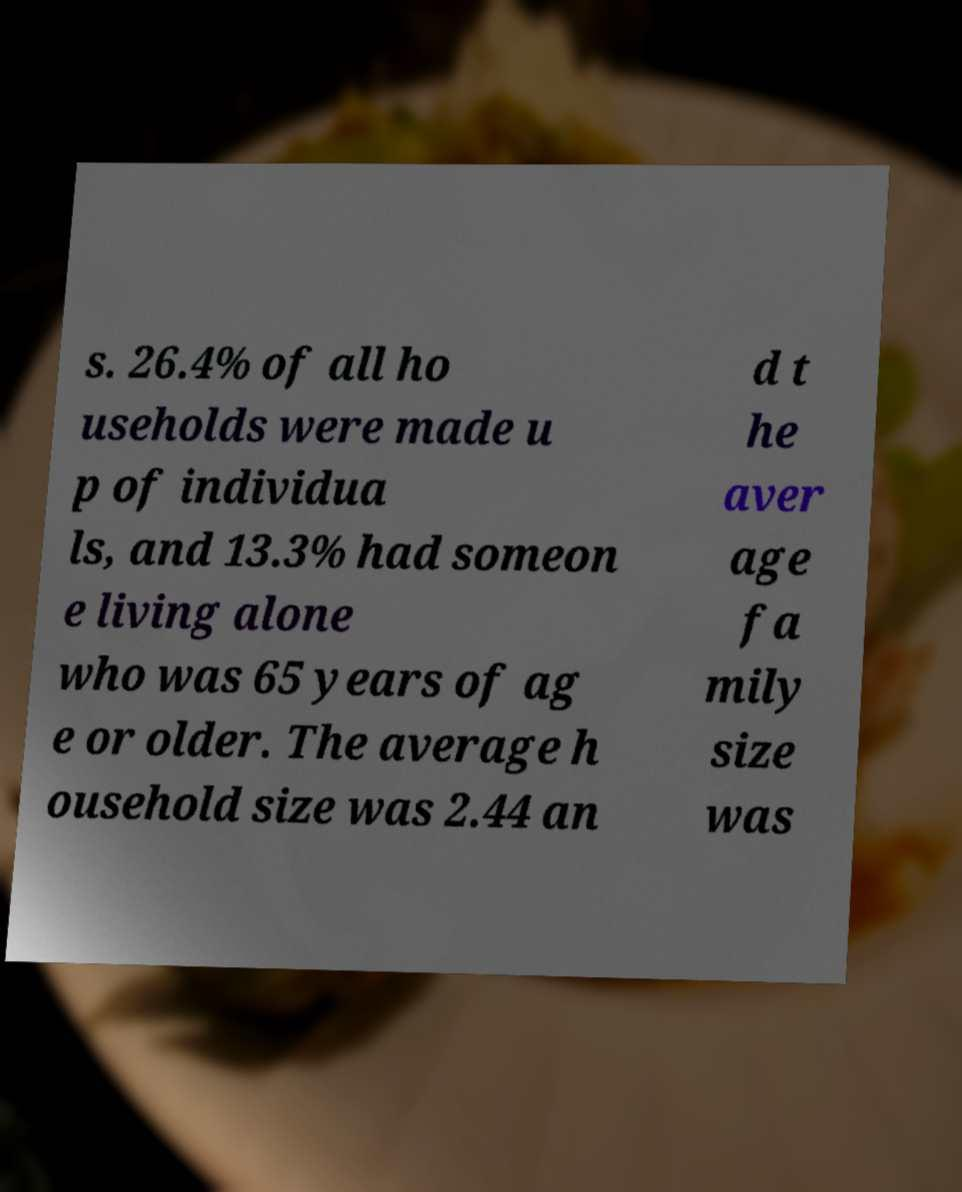Please read and relay the text visible in this image. What does it say? s. 26.4% of all ho useholds were made u p of individua ls, and 13.3% had someon e living alone who was 65 years of ag e or older. The average h ousehold size was 2.44 an d t he aver age fa mily size was 